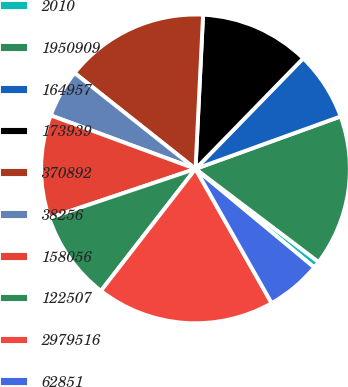Convert chart. <chart><loc_0><loc_0><loc_500><loc_500><pie_chart><fcel>2010<fcel>1950909<fcel>164957<fcel>173939<fcel>370892<fcel>38256<fcel>158056<fcel>122507<fcel>2979516<fcel>62851<nl><fcel>0.72%<fcel>15.83%<fcel>7.19%<fcel>11.51%<fcel>15.11%<fcel>5.04%<fcel>10.79%<fcel>9.35%<fcel>18.71%<fcel>5.76%<nl></chart> 